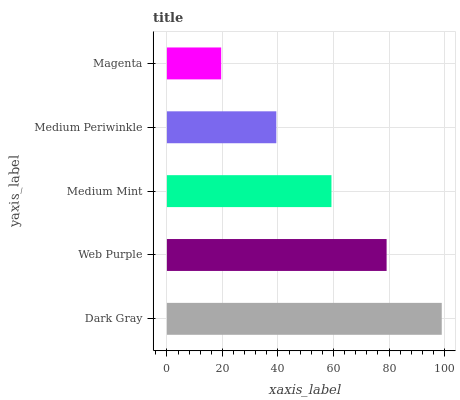Is Magenta the minimum?
Answer yes or no. Yes. Is Dark Gray the maximum?
Answer yes or no. Yes. Is Web Purple the minimum?
Answer yes or no. No. Is Web Purple the maximum?
Answer yes or no. No. Is Dark Gray greater than Web Purple?
Answer yes or no. Yes. Is Web Purple less than Dark Gray?
Answer yes or no. Yes. Is Web Purple greater than Dark Gray?
Answer yes or no. No. Is Dark Gray less than Web Purple?
Answer yes or no. No. Is Medium Mint the high median?
Answer yes or no. Yes. Is Medium Mint the low median?
Answer yes or no. Yes. Is Web Purple the high median?
Answer yes or no. No. Is Medium Periwinkle the low median?
Answer yes or no. No. 